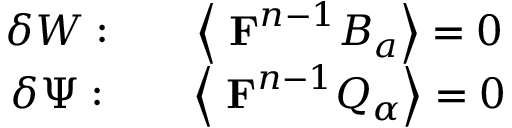<formula> <loc_0><loc_0><loc_500><loc_500>\begin{array} { c c c } { \delta W \colon } & { { \left \langle { F } ^ { n - 1 } B _ { a } \right \rangle = 0 } } \\ { \delta \Psi \colon } & { { \left \langle { F } ^ { n - 1 } Q _ { \alpha } \right \rangle = 0 } } \end{array}</formula> 